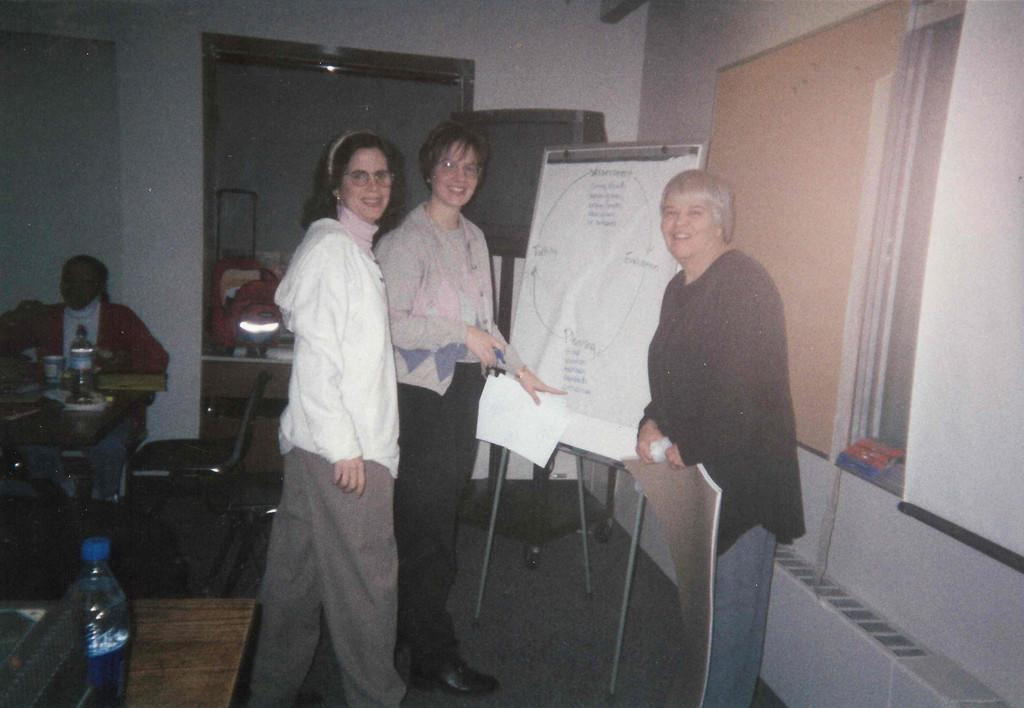How many women are present in the image? There are three women in the image. What are the women doing in the image? The women are standing in front of a camera. What objects can be seen in the image besides the women? There is a board, chairs, a table, and a water bottle placed on the table in the image. What type of hospital equipment can be seen in the image? There is no hospital equipment present in the image. Can you describe the coil that is being used by the women in the image? There is no coil present in the image; the women are standing in front of a camera. 